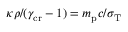Convert formula to latex. <formula><loc_0><loc_0><loc_500><loc_500>\kappa \rho / ( \gamma _ { c r } - 1 ) = m _ { p } c / \sigma _ { T }</formula> 